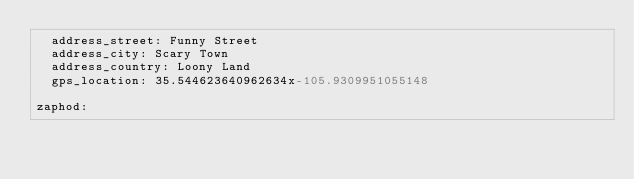<code> <loc_0><loc_0><loc_500><loc_500><_YAML_>  address_street: Funny Street
  address_city: Scary Town
  address_country: Loony Land
  gps_location: 35.544623640962634x-105.9309951055148

zaphod:</code> 